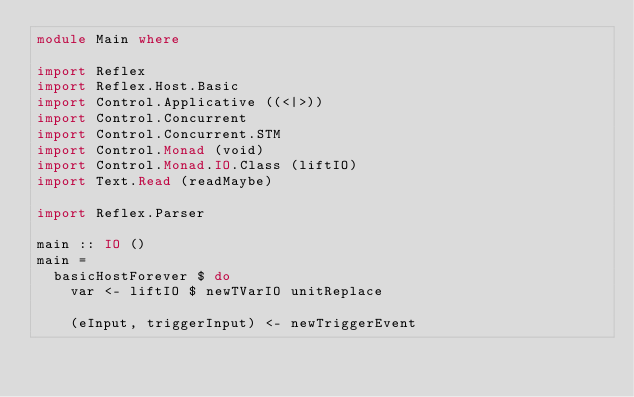Convert code to text. <code><loc_0><loc_0><loc_500><loc_500><_Haskell_>module Main where

import Reflex
import Reflex.Host.Basic
import Control.Applicative ((<|>))
import Control.Concurrent
import Control.Concurrent.STM
import Control.Monad (void)
import Control.Monad.IO.Class (liftIO)
import Text.Read (readMaybe)

import Reflex.Parser

main :: IO ()
main =
  basicHostForever $ do
    var <- liftIO $ newTVarIO unitReplace

    (eInput, triggerInput) <- newTriggerEvent</code> 